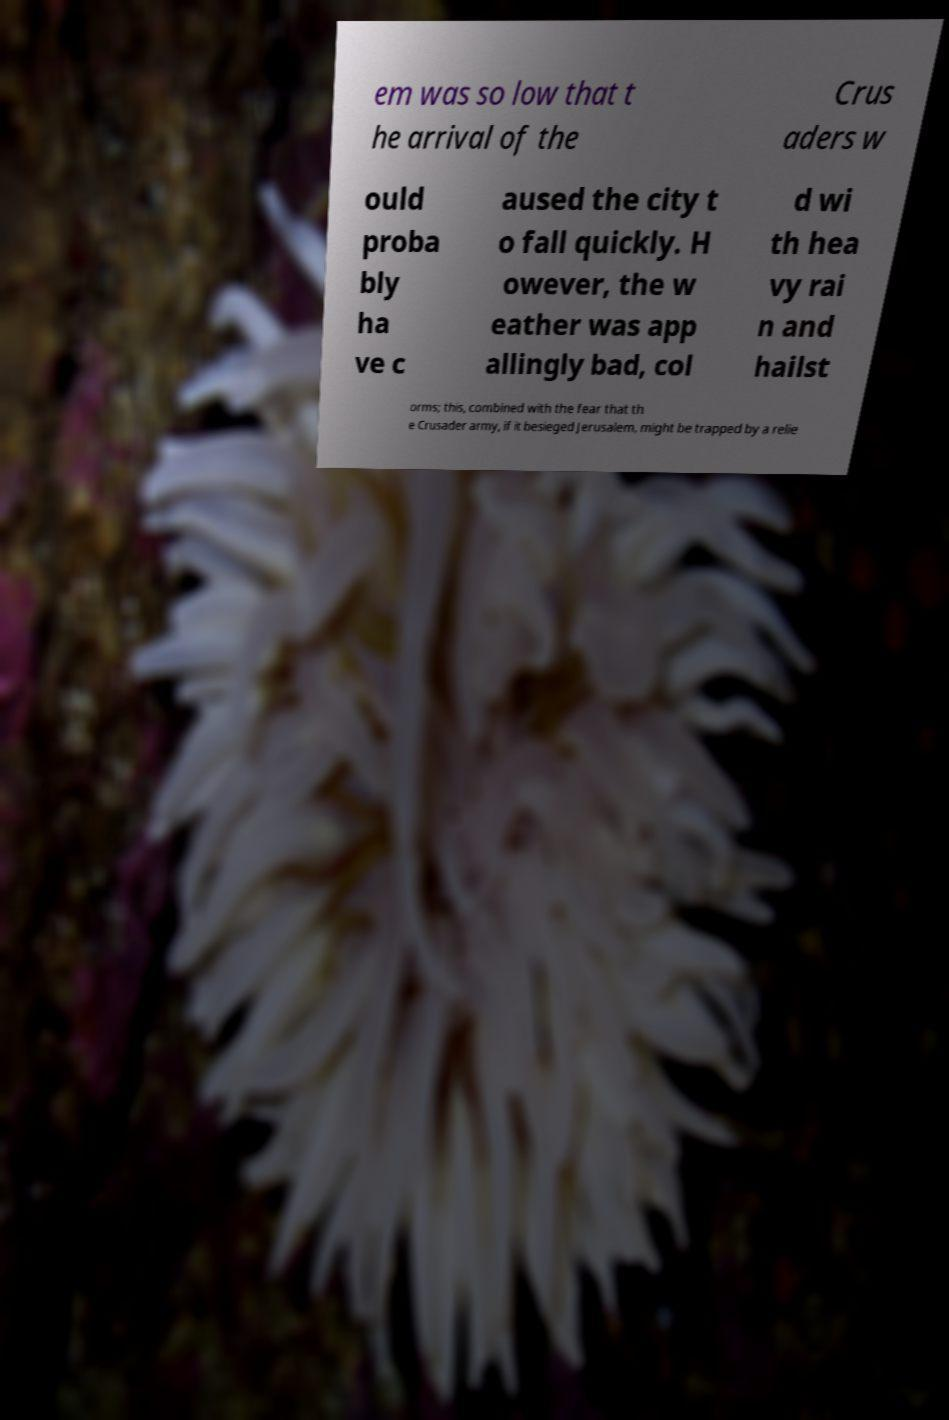Could you extract and type out the text from this image? em was so low that t he arrival of the Crus aders w ould proba bly ha ve c aused the city t o fall quickly. H owever, the w eather was app allingly bad, col d wi th hea vy rai n and hailst orms; this, combined with the fear that th e Crusader army, if it besieged Jerusalem, might be trapped by a relie 